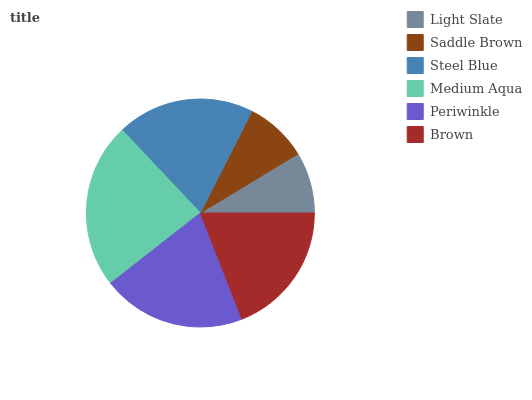Is Light Slate the minimum?
Answer yes or no. Yes. Is Medium Aqua the maximum?
Answer yes or no. Yes. Is Saddle Brown the minimum?
Answer yes or no. No. Is Saddle Brown the maximum?
Answer yes or no. No. Is Saddle Brown greater than Light Slate?
Answer yes or no. Yes. Is Light Slate less than Saddle Brown?
Answer yes or no. Yes. Is Light Slate greater than Saddle Brown?
Answer yes or no. No. Is Saddle Brown less than Light Slate?
Answer yes or no. No. Is Steel Blue the high median?
Answer yes or no. Yes. Is Brown the low median?
Answer yes or no. Yes. Is Brown the high median?
Answer yes or no. No. Is Saddle Brown the low median?
Answer yes or no. No. 